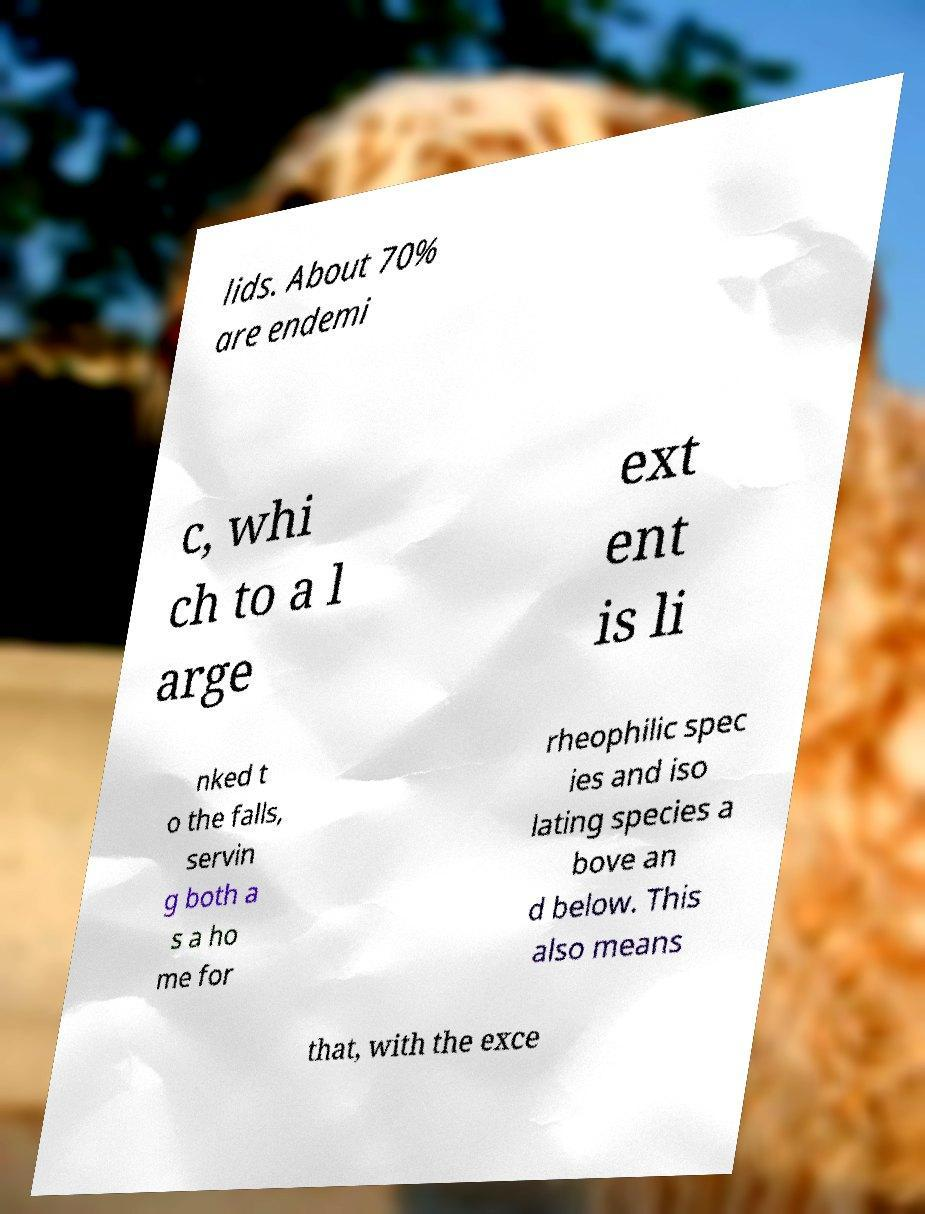What messages or text are displayed in this image? I need them in a readable, typed format. lids. About 70% are endemi c, whi ch to a l arge ext ent is li nked t o the falls, servin g both a s a ho me for rheophilic spec ies and iso lating species a bove an d below. This also means that, with the exce 